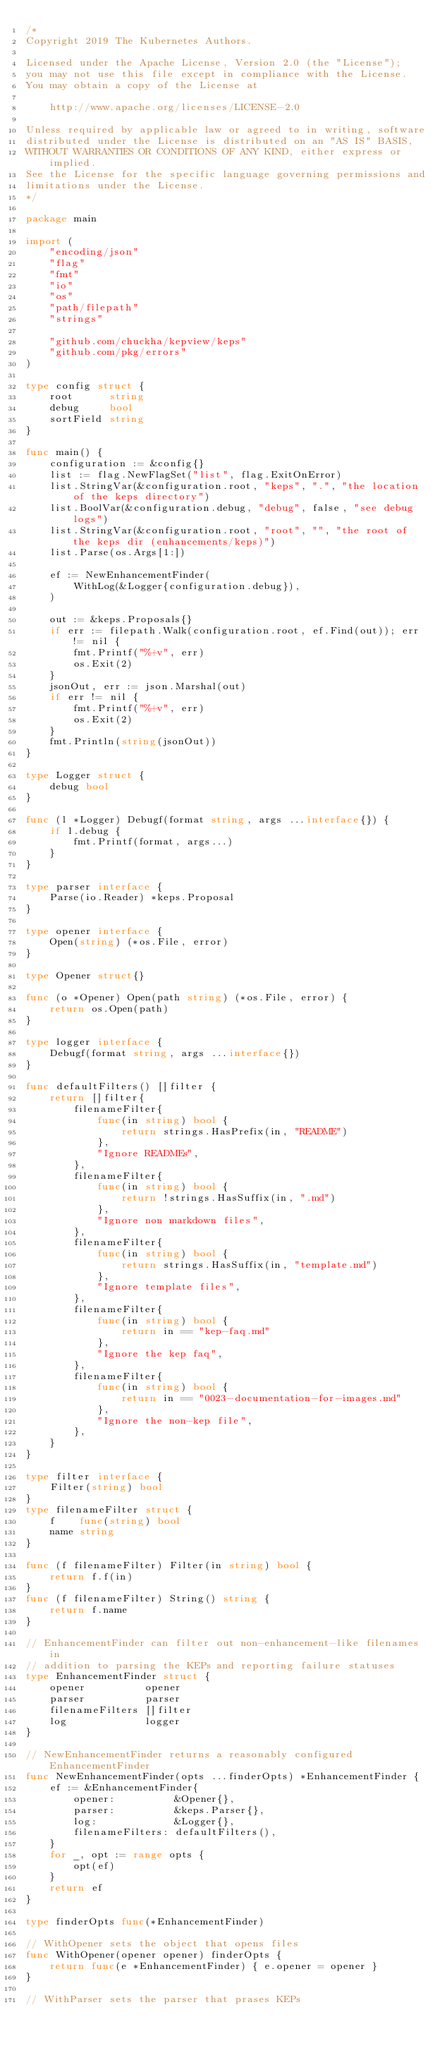<code> <loc_0><loc_0><loc_500><loc_500><_Go_>/*
Copyright 2019 The Kubernetes Authors.

Licensed under the Apache License, Version 2.0 (the "License");
you may not use this file except in compliance with the License.
You may obtain a copy of the License at

    http://www.apache.org/licenses/LICENSE-2.0

Unless required by applicable law or agreed to in writing, software
distributed under the License is distributed on an "AS IS" BASIS,
WITHOUT WARRANTIES OR CONDITIONS OF ANY KIND, either express or implied.
See the License for the specific language governing permissions and
limitations under the License.
*/

package main

import (
	"encoding/json"
	"flag"
	"fmt"
	"io"
	"os"
	"path/filepath"
	"strings"

	"github.com/chuckha/kepview/keps"
	"github.com/pkg/errors"
)

type config struct {
	root      string
	debug     bool
	sortField string
}

func main() {
	configuration := &config{}
	list := flag.NewFlagSet("list", flag.ExitOnError)
	list.StringVar(&configuration.root, "keps", ".", "the location of the keps directory")
	list.BoolVar(&configuration.debug, "debug", false, "see debug logs")
	list.StringVar(&configuration.root, "root", "", "the root of the keps dir (enhancements/keps)")
	list.Parse(os.Args[1:])

	ef := NewEnhancementFinder(
		WithLog(&Logger{configuration.debug}),
	)

	out := &keps.Proposals{}
	if err := filepath.Walk(configuration.root, ef.Find(out)); err != nil {
		fmt.Printf("%+v", err)
		os.Exit(2)
	}
	jsonOut, err := json.Marshal(out)
	if err != nil {
		fmt.Printf("%+v", err)
		os.Exit(2)
	}
	fmt.Println(string(jsonOut))
}

type Logger struct {
	debug bool
}

func (l *Logger) Debugf(format string, args ...interface{}) {
	if l.debug {
		fmt.Printf(format, args...)
	}
}

type parser interface {
	Parse(io.Reader) *keps.Proposal
}

type opener interface {
	Open(string) (*os.File, error)
}

type Opener struct{}

func (o *Opener) Open(path string) (*os.File, error) {
	return os.Open(path)
}

type logger interface {
	Debugf(format string, args ...interface{})
}

func defaultFilters() []filter {
	return []filter{
		filenameFilter{
			func(in string) bool {
				return strings.HasPrefix(in, "README")
			},
			"Ignore READMEs",
		},
		filenameFilter{
			func(in string) bool {
				return !strings.HasSuffix(in, ".md")
			},
			"Ignore non markdown files",
		},
		filenameFilter{
			func(in string) bool {
				return strings.HasSuffix(in, "template.md")
			},
			"Ignore template files",
		},
		filenameFilter{
			func(in string) bool {
				return in == "kep-faq.md"
			},
			"Ignore the kep faq",
		},
		filenameFilter{
			func(in string) bool {
				return in == "0023-documentation-for-images.md"
			},
			"Ignore the non-kep file",
		},
	}
}

type filter interface {
	Filter(string) bool
}
type filenameFilter struct {
	f    func(string) bool
	name string
}

func (f filenameFilter) Filter(in string) bool {
	return f.f(in)
}
func (f filenameFilter) String() string {
	return f.name
}

// EnhancementFinder can filter out non-enhancement-like filenames in
// addition to parsing the KEPs and reporting failure statuses
type EnhancementFinder struct {
	opener          opener
	parser          parser
	filenameFilters []filter
	log             logger
}

// NewEnhancementFinder returns a reasonably configured EnhancementFinder
func NewEnhancementFinder(opts ...finderOpts) *EnhancementFinder {
	ef := &EnhancementFinder{
		opener:          &Opener{},
		parser:          &keps.Parser{},
		log:             &Logger{},
		filenameFilters: defaultFilters(),
	}
	for _, opt := range opts {
		opt(ef)
	}
	return ef
}

type finderOpts func(*EnhancementFinder)

// WithOpener sets the object that opens files
func WithOpener(opener opener) finderOpts {
	return func(e *EnhancementFinder) { e.opener = opener }
}

// WithParser sets the parser that prases KEPs</code> 